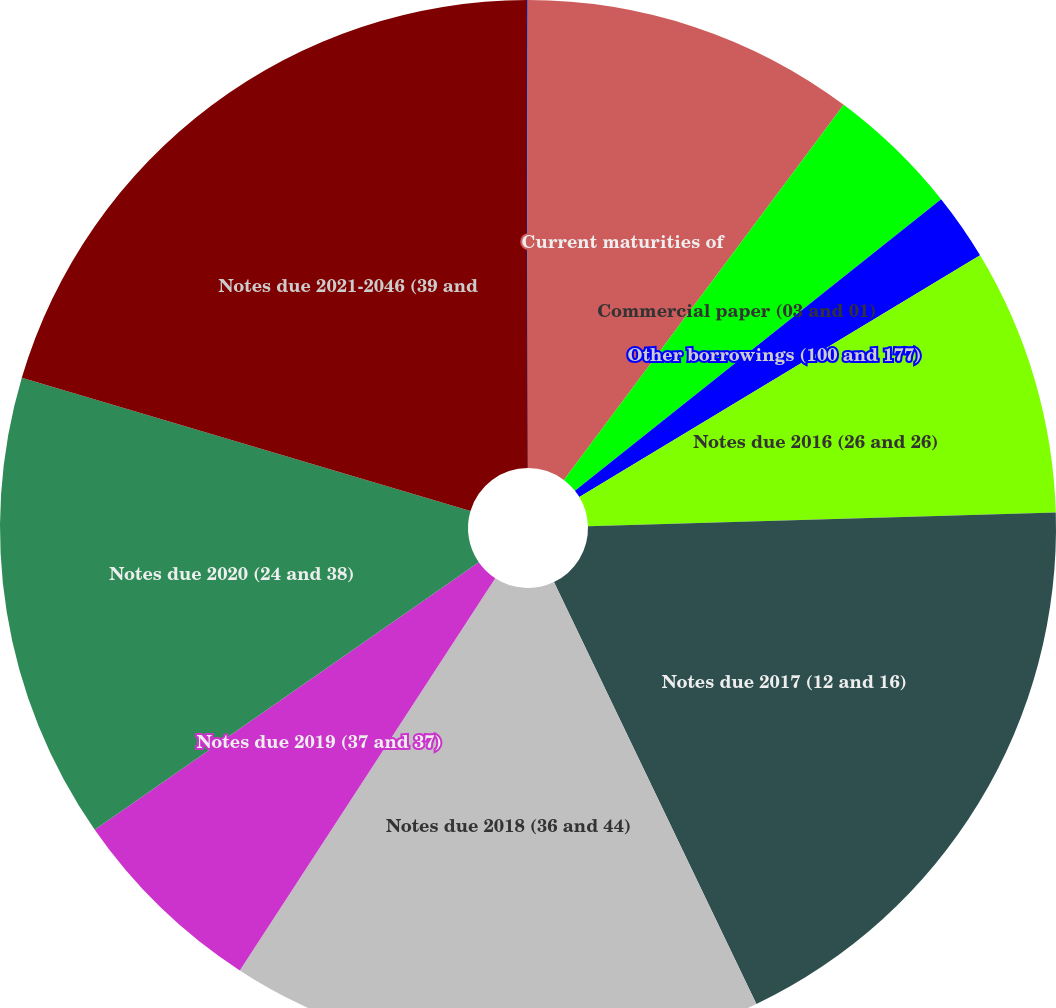Convert chart to OTSL. <chart><loc_0><loc_0><loc_500><loc_500><pie_chart><fcel>Current maturities of<fcel>Commercial paper (03 and 01)<fcel>Other borrowings (100 and 177)<fcel>Notes due 2016 (26 and 26)<fcel>Notes due 2017 (12 and 16)<fcel>Notes due 2018 (36 and 44)<fcel>Notes due 2019 (37 and 37)<fcel>Notes due 2020 (24 and 38)<fcel>Notes due 2021-2046 (39 and<fcel>Other due 2016-2021 (43 and<nl><fcel>10.2%<fcel>4.1%<fcel>2.06%<fcel>8.17%<fcel>18.35%<fcel>16.31%<fcel>6.13%<fcel>14.27%<fcel>20.38%<fcel>0.03%<nl></chart> 